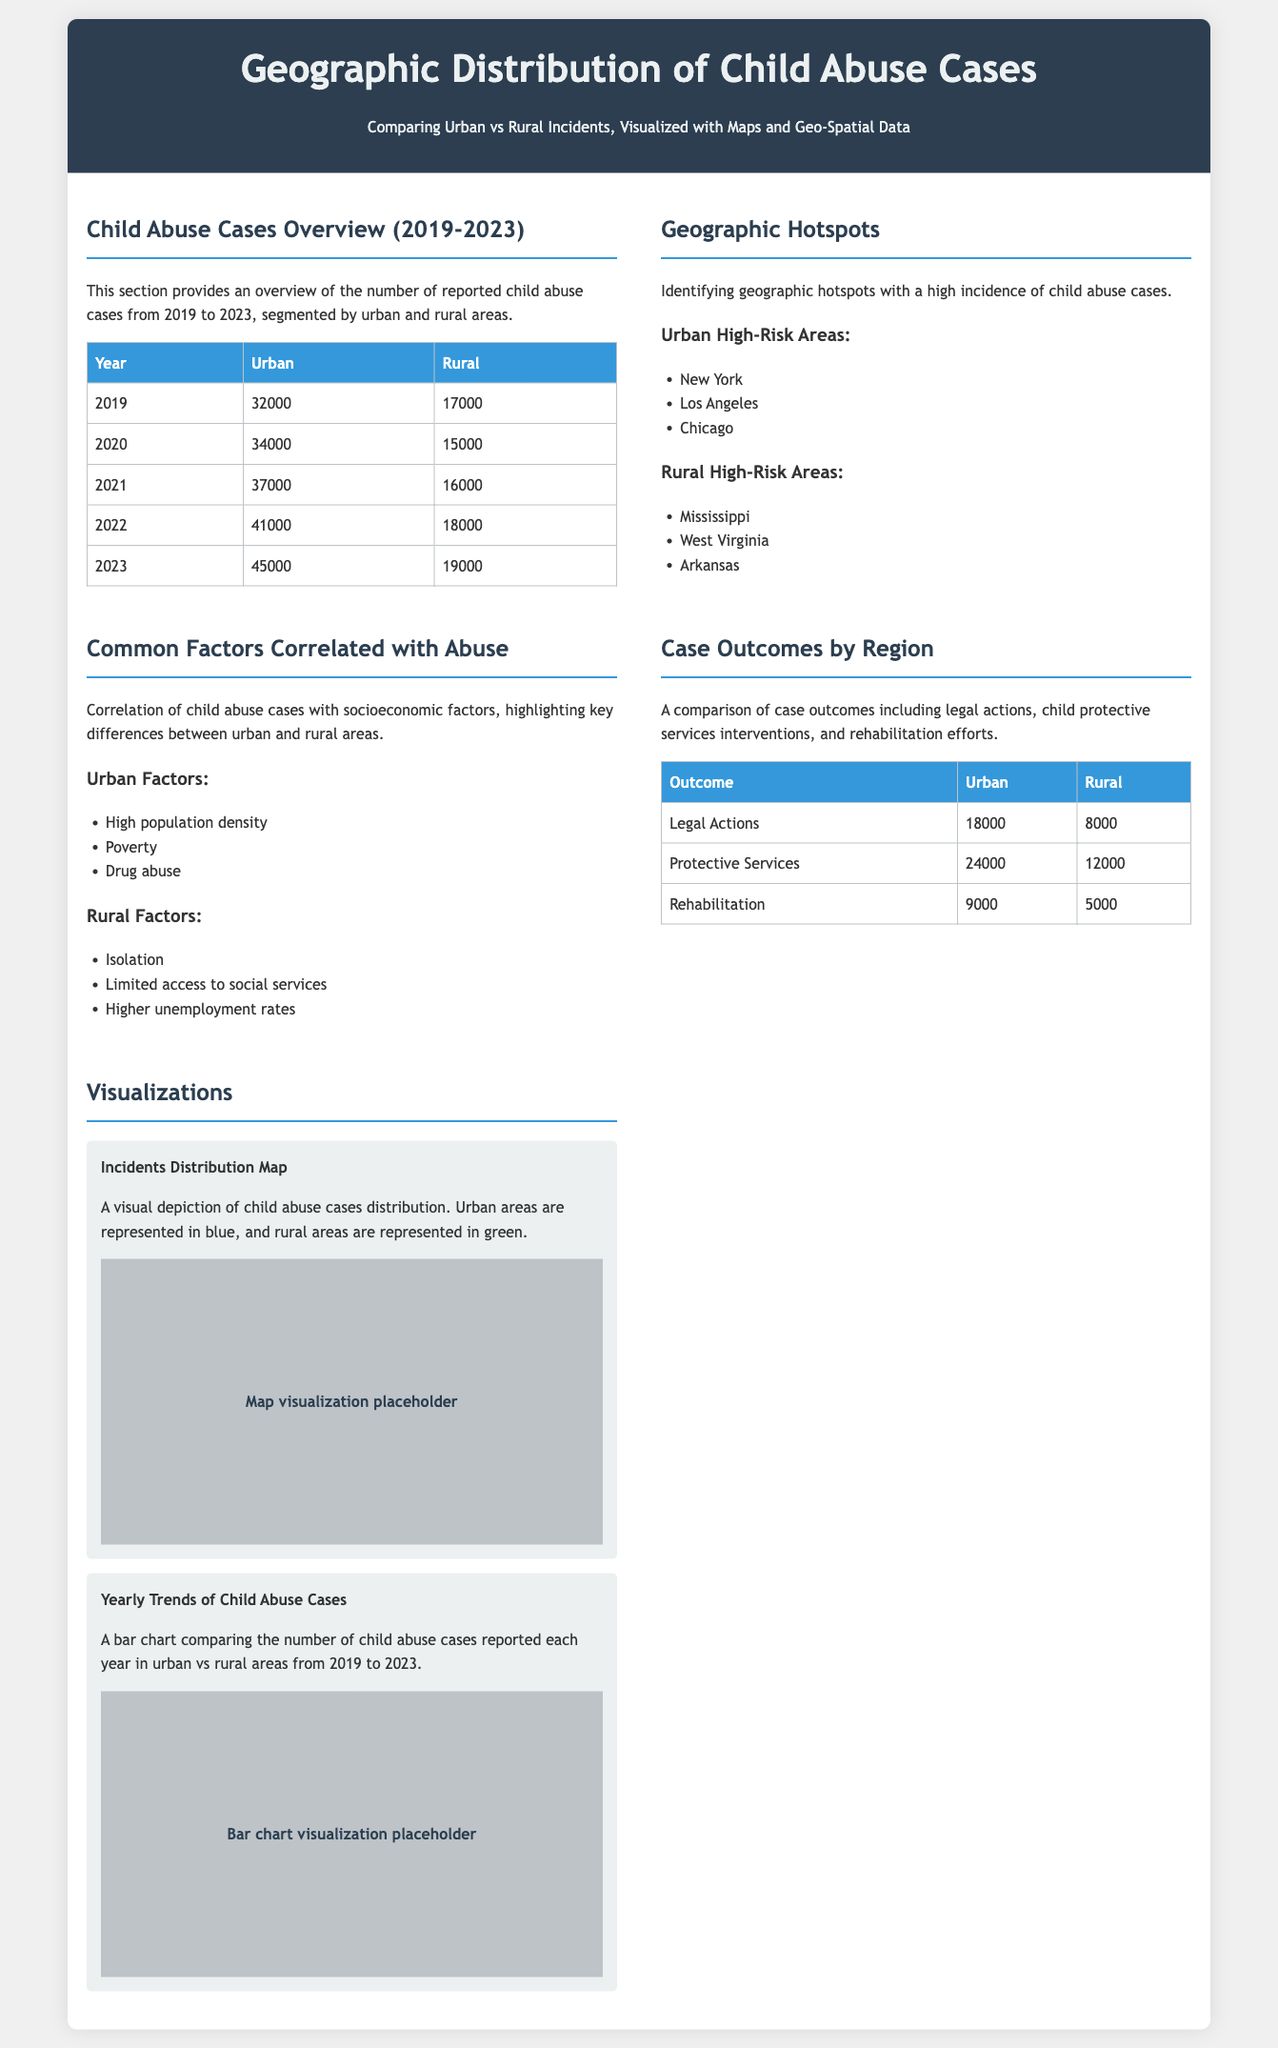What was the number of child abuse cases in urban areas in 2021? The document states that in 2021, there were 37000 reported child abuse cases in urban areas.
Answer: 37000 Which rural area is identified as a high-risk area for child abuse? The document lists Mississippi as one of the rural high-risk areas for child abuse.
Answer: Mississippi What is the total number of reported child abuse cases in 2023? The document shows that there were 45000 reported child abuse cases in urban areas and 19000 in rural areas in 2023, totaling 64000.
Answer: 64000 What common factor is mentioned that correlates with abuse in urban areas? The document highlights high population density as a common factor correlating with child abuse in urban areas.
Answer: High population density How many protective services interventions were recorded in rural areas? The document specifies that 12000 protective services interventions were recorded in rural areas.
Answer: 12000 Which year had the highest number of child abuse cases in urban areas? The document states that the year 2023 had the highest number of reported child abuse cases in urban areas, with 45000 cases.
Answer: 2023 What visualization is provided to depict the distribution of child abuse cases? The document includes a map visualization depicting the incidents distribution of child abuse cases.
Answer: Map visualization Which urban area is listed among the highest risk for child abuse cases? The document mentions Los Angeles as one of the urban high-risk areas for child abuse.
Answer: Los Angeles 